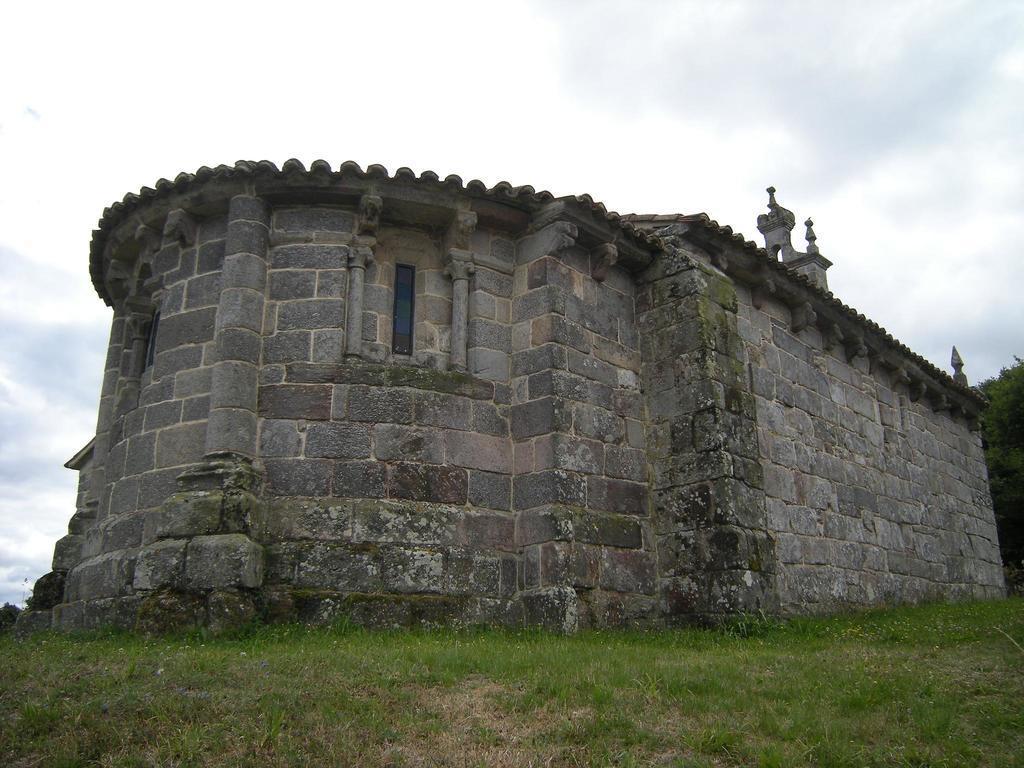Describe this image in one or two sentences. In this picture we can see a building with windows, grass, trees and in the background we can see the sky with clouds. 